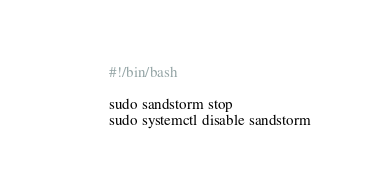<code> <loc_0><loc_0><loc_500><loc_500><_Bash_>#!/bin/bash

sudo sandstorm stop
sudo systemctl disable sandstorm
</code> 